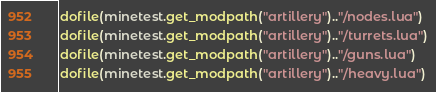Convert code to text. <code><loc_0><loc_0><loc_500><loc_500><_Lua_>dofile(minetest.get_modpath("artillery").."/nodes.lua")
dofile(minetest.get_modpath("artillery").."/turrets.lua")
dofile(minetest.get_modpath("artillery").."/guns.lua")
dofile(minetest.get_modpath("artillery").."/heavy.lua")</code> 